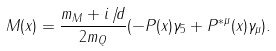<formula> <loc_0><loc_0><loc_500><loc_500>M ( x ) = \frac { m _ { M } + i { \not \, d } } { 2 m _ { Q } } ( - P ( x ) \gamma _ { 5 } + P ^ { * \mu } ( x ) \gamma _ { \mu } ) .</formula> 